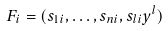<formula> <loc_0><loc_0><loc_500><loc_500>F _ { i } = ( s _ { 1 i } , \dots , s _ { n i } , s _ { l i } y ^ { l } )</formula> 